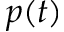<formula> <loc_0><loc_0><loc_500><loc_500>p ( t )</formula> 